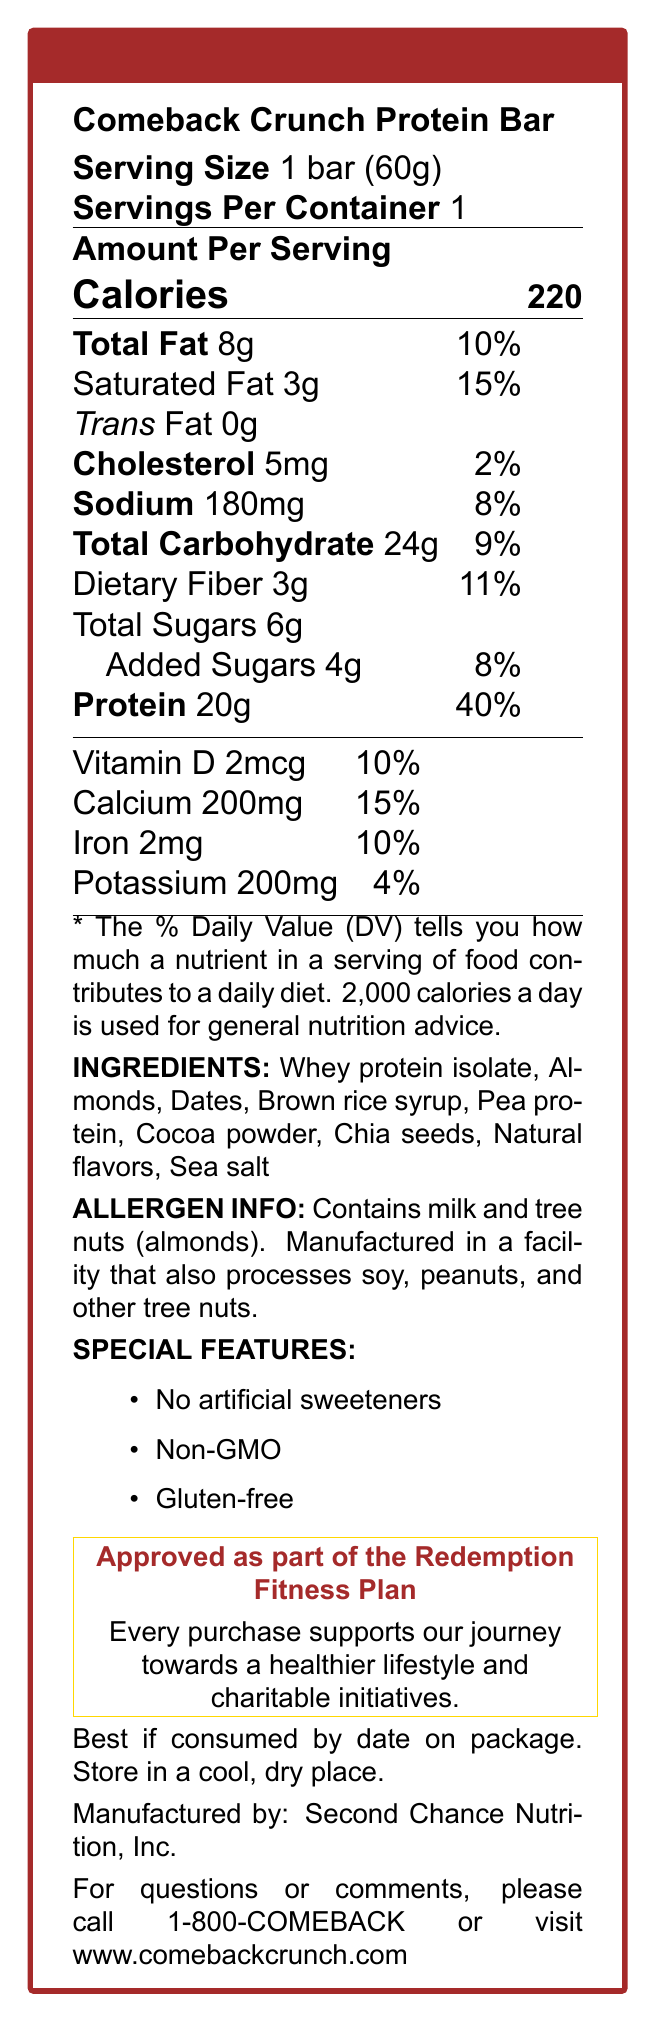what is the serving size of the Comeback Crunch Protein Bar? The document mentions the serving size as "1 bar (60g)" under the Nutrition Facts.
Answer: 1 bar (60g) how many calories are in one serving of the protein bar? The label states the amount of calories per serving is "220".
Answer: 220 what is the percentage of daily value for protein in this protein bar? The document lists the daily value percentage for protein as "40%" in the nutrition facts.
Answer: 40% how much total fat does the Comeback Crunch Protein Bar contain? The total fat content is listed as "8g" in the document.
Answer: 8g what are the three key special features of the protein bar? The special features include: "No artificial sweeteners," "Non-GMO," and "Gluten-free," as stated in the document.
Answer: No artificial sweeteners, Non-GMO, Gluten-free how much dietary fiber is in one serving of the protein bar? The dietary fiber amount is mentioned as "3g" in the nutrition facts.
Answer: 3g what is the sodium content in one serving? The sodium content is listed as "180mg" in the nutrition facts.
Answer: 180mg what is the percentage of daily value for calcium provided by this protein bar? The document mentions the daily value percentage for calcium as "15%".
Answer: 15% which of the following ingredients is NOT included in the protein bar? A. Pea protein B. Almonds C. Soy protein D. Cocoa powder The listed ingredients include "Pea protein," "Almonds," and "Cocoa powder," but not "Soy protein."
Answer: C. Soy protein what is the amount of added sugars per serving? The document lists "Added Sugars" as "4g".
Answer: 4g is there any trans fat in the protein bar? The label indicates "Trans Fat" as "0g".
Answer: No what should you do if you have questions or comments about the protein bar? The contact information provided is to call 1-800-COMEBACK or visit www.comebackcrunch.com.
Answer: Call 1-800-COMEBACK or visit www.comebackcrunch.com why should purchases of this protein bar be encouraged according to the document? The label states that every purchase supports the celebrity's journey towards a healthier lifestyle and charitable initiatives.
Answer: Supports the celebrity's journey towards a healthier lifestyle and charitable initiatives what allergens does the protein bar contain? The allergen info in the document states that it contains milk and tree nuts (almonds).
Answer: Milk and tree nuts (almonds) does the protein bar include any vitamin D? The document lists Vitamin D as "2mcg," covering 10% of the daily value.
Answer: Yes what is the total carbohydrate content per serving? The total carbohydrate amount is listed as "24g" in the nutrition facts.
Answer: 24g summarize the main benefits and purpose of the Comeback Crunch Protein Bar. This protein bar is designed to support a healthier lifestyle and includes benefits like no artificial sweeteners, non-GMO, and gluten-free ingredients. Additionally, it aids the celebrity's redemption journey and charitable causes.
Answer: The Comeback Crunch Protein Bar provides a good amount of protein (20g) with various health features like no artificial sweeteners, non-GMO, and gluten-free. It supports the celebrity's fitness journey and contributes to charitable initiatives. how many servings are there in one container of the protein bar? The document states "Servings Per Container: 1".
Answer: 1 which company manufactures the Comeback Crunch Protein Bar? The manufacturer's information is listed as "Second Chance Nutrition, Inc."
Answer: Second Chance Nutrition, Inc. when is the product best consumed by? The document advises to check the date on the package for the best consumption time.
Answer: Date on the package is the protein bar non-GMO? Under special features, the document lists "Non-GMO."
Answer: Yes what is the celebrity's name who endorses the protein bar? The document refers to the endorsing celebrity as "[Celebrity Name]" without specifying an actual name.
Answer: Cannot be determined 